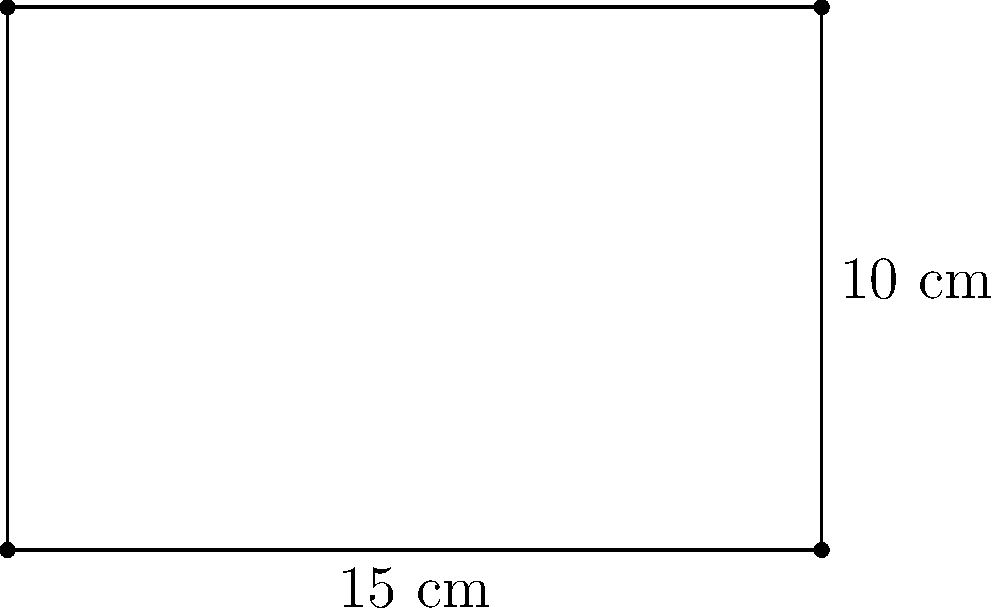As a dedicated fan of Elevation Worship, you're designing a custom music sheet for their latest song. The rectangular sheet measures 15 cm in width and 10 cm in height. Calculate the perimeter of this music sheet. Let's approach this step-by-step:

1) The perimeter of a rectangle is the sum of all its sides.

2) The formula for the perimeter of a rectangle is:
   $$P = 2l + 2w$$
   where $P$ is the perimeter, $l$ is the length (height in this case), and $w$ is the width.

3) We are given:
   Width ($w$) = 15 cm
   Height ($l$) = 10 cm

4) Let's substitute these values into our formula:
   $$P = 2(10) + 2(15)$$

5) Now, let's calculate:
   $$P = 20 + 30 = 50$$

Therefore, the perimeter of the music sheet is 50 cm.
Answer: 50 cm 